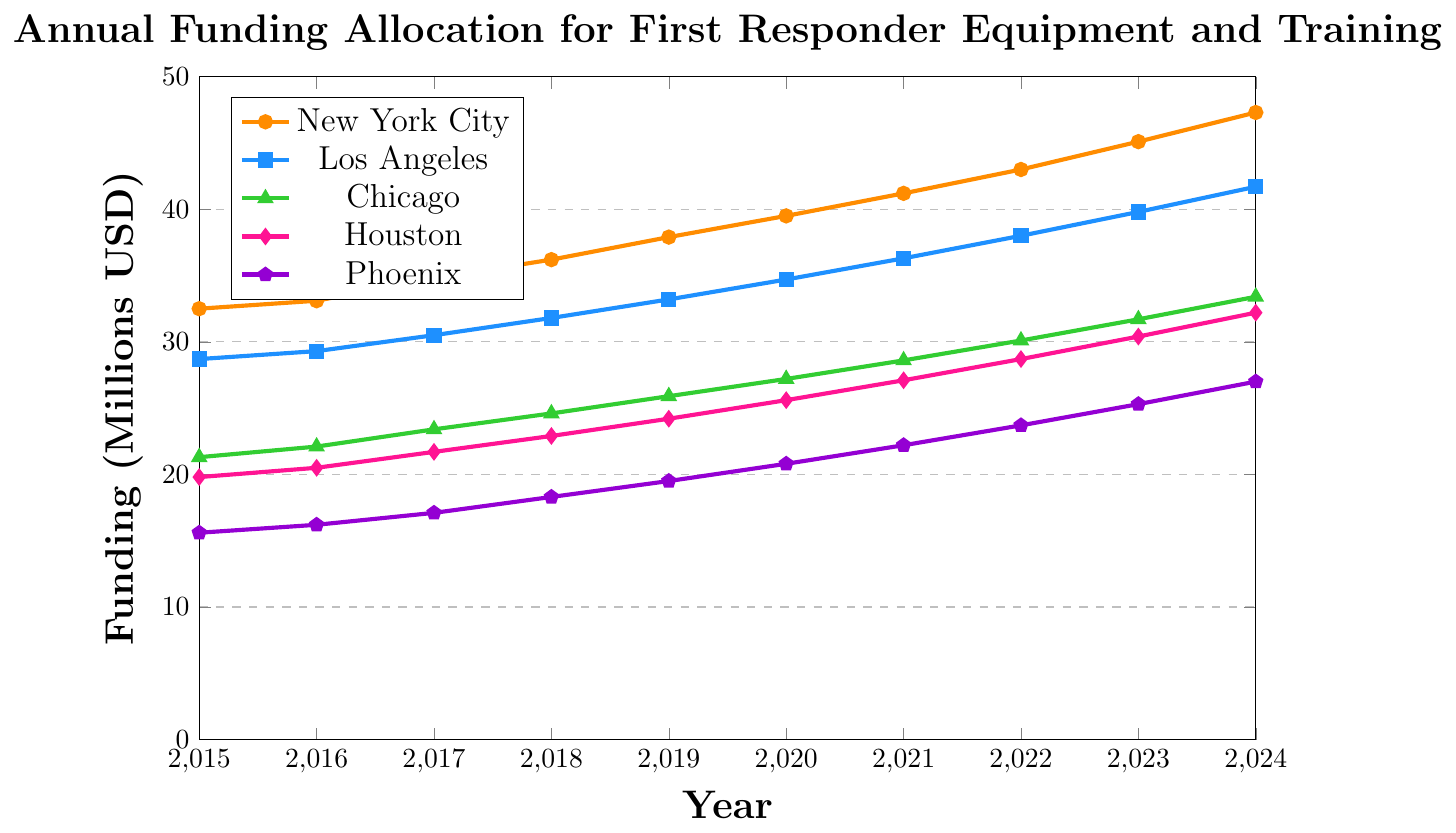Which city had the highest funding allocation in 2024? The figure shows the funding allocation for various cities over the years. To answer this question, identify the plotted line that reaches the highest point on the y-axis in 2024, which is marked on the x-axis.
Answer: New York City What was the difference in funding allocation between Los Angeles and Chicago in 2020? Locate the funding values for Los Angeles and Chicago in 2020 from the plotted lines. Subtract the value for Chicago from the value for Los Angeles: 34.7 - 27.2
Answer: 7.5 million USD How much did Houston's funding increase from 2015 to 2024? Look at Houston’s funding in 2015 and 2024. Subtract the value in 2015 from the value in 2024: 32.2 - 19.8
Answer: 12.4 million USD Which city showed the greatest increase in funding from 2015 to 2024? Calculate the difference in funding for each city from 2015 to 2024 and compare them. New York City: 47.3 - 32.5 = 14.8, Los Angeles: 41.7 - 28.7 = 13.0, Chicago: 33.4 - 21.3 = 12.1, Houston: 32.2 - 19.8 = 12.4, Phoenix: 27.0 - 15.6 = 11.4. New York City has the greatest increase.
Answer: New York City What is the average funding allocation for Phoenix from 2015 to 2024? To find the average, sum the funding values for Phoenix from 2015 to 2024 and divide by the number of years. Sum: 15.6 + 16.2 + 17.1 + 18.3 + 19.5 + 20.8 + 22.2 + 23.7 + 25.3 + 27.0 = 206.7. Average: 206.7 / 10 = 20.67
Answer: 20.67 million USD In which year did Chicago’s funding surpass 25 million USD for the first time? Review the plot for Chicago’s funding progression and identify the first year where the funding exceeds 25 million USD. This happens between 2018 and 2019, with the precise value in 2019 being 25.9 million USD.
Answer: 2019 How does the funding trend for Houston compare to that of Phoenix from 2015 to 2024? Compare the slopes of the lines representing funding allocations for Houston and Phoenix. Both lines show a consistent upward trend, but Houston’s slope is steeper indicating a faster increase in funding over the years.
Answer: Houston increases faster than Phoenix Which city had the least change in funding allocation from 2015 to 2024? Calculate the difference in funding for each city from 2015 to 2024 and identify the city with the smallest change. Phoenix: 27.0 - 15.6 = 11.4, Houston: 32.2 - 19.8 = 12.4, Chicago: 33.4 - 21.3 = 12.1, Los Angeles: 41.7 - 28.7 = 13.0, New York City: 47.3 - 32.5 = 14.8. Phoenix has the smallest change.
Answer: Phoenix 